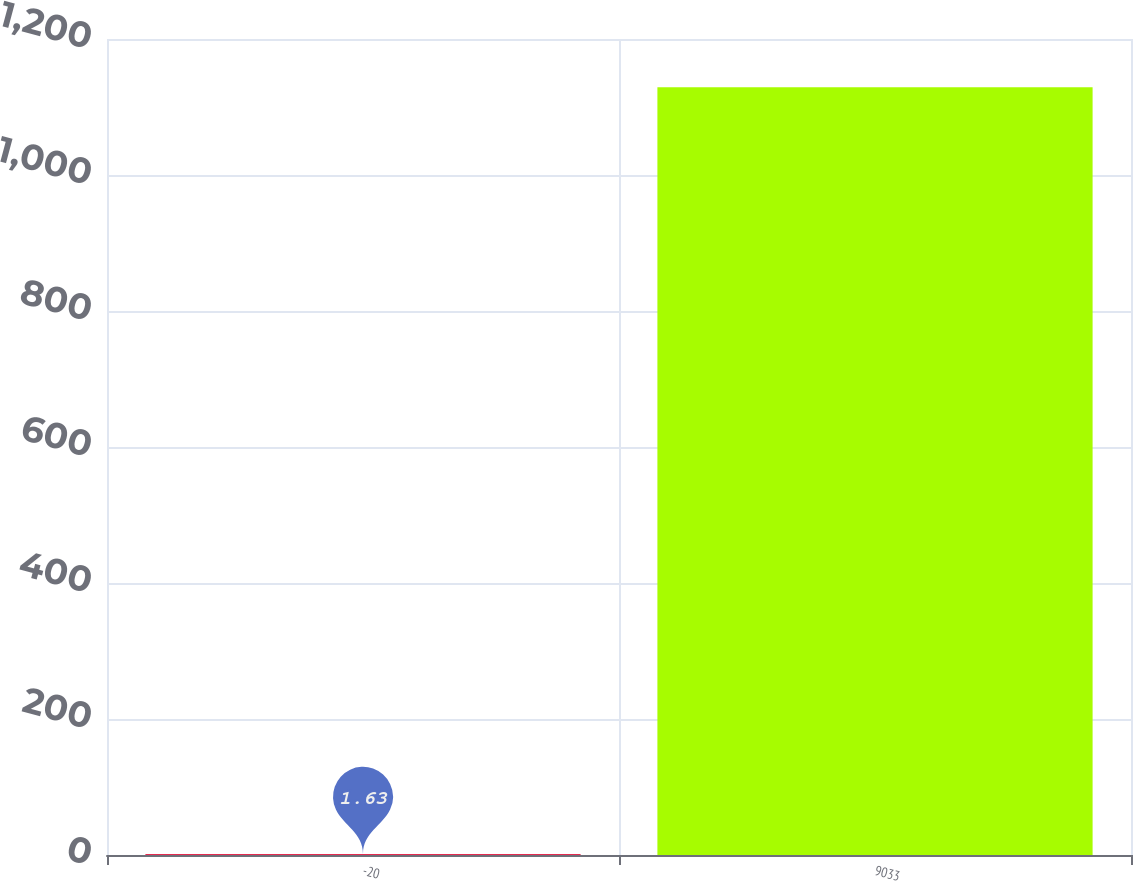<chart> <loc_0><loc_0><loc_500><loc_500><bar_chart><fcel>-20<fcel>9033<nl><fcel>1.63<fcel>1129.2<nl></chart> 